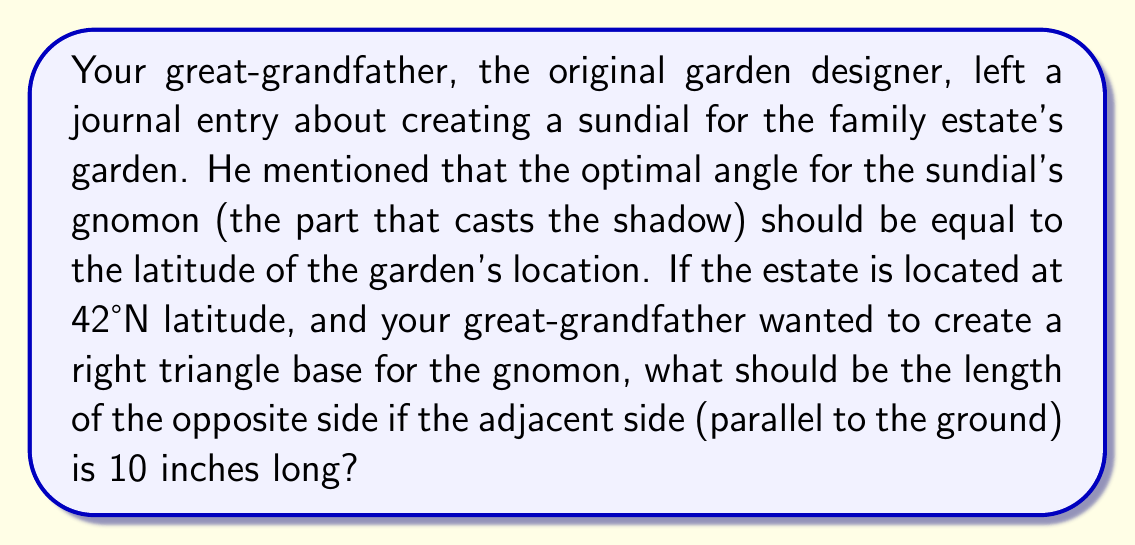Could you help me with this problem? To solve this problem, we need to use trigonometry, specifically the tangent function. Let's break it down step-by-step:

1. The optimal angle for the sundial's gnomon is equal to the latitude: 42°

2. We're dealing with a right triangle where:
   - The angle we're interested in is 42°
   - The adjacent side (parallel to the ground) is 10 inches
   - We need to find the opposite side (the height of the gnomon)

3. In a right triangle, tangent of an angle is the ratio of the opposite side to the adjacent side:

   $$\tan(\theta) = \frac{\text{opposite}}{\text{adjacent}}$$

4. We can rearrange this to solve for the opposite side:

   $$\text{opposite} = \text{adjacent} \times \tan(\theta)$$

5. Plugging in our known values:

   $$\text{opposite} = 10 \times \tan(42°)$$

6. Using a calculator or trigonometric table to evaluate $\tan(42°)$:

   $$\tan(42°) \approx 0.900404$$

7. Therefore:

   $$\text{opposite} = 10 \times 0.900404 = 9.00404 \text{ inches}$$

[asy]
import geometry;

size(200);

pair A = (0,0), B = (10,0), C = (10,9.00404);
draw(A--B--C--A);

draw(B--(B+(1,0)), arrow=Arrow(TeXHead));
draw(B--(B+(0,1)), arrow=Arrow(TeXHead));

label("10\"", (A+B)/2, S);
label("9.00\"", (B+C)/2, E);
label("42°", A, NW);

dot("A", A, SW);
dot("B", B, SE);
dot("C", C, NE);
[/asy]
Answer: The length of the opposite side (height of the gnomon) should be approximately 9.00 inches. 